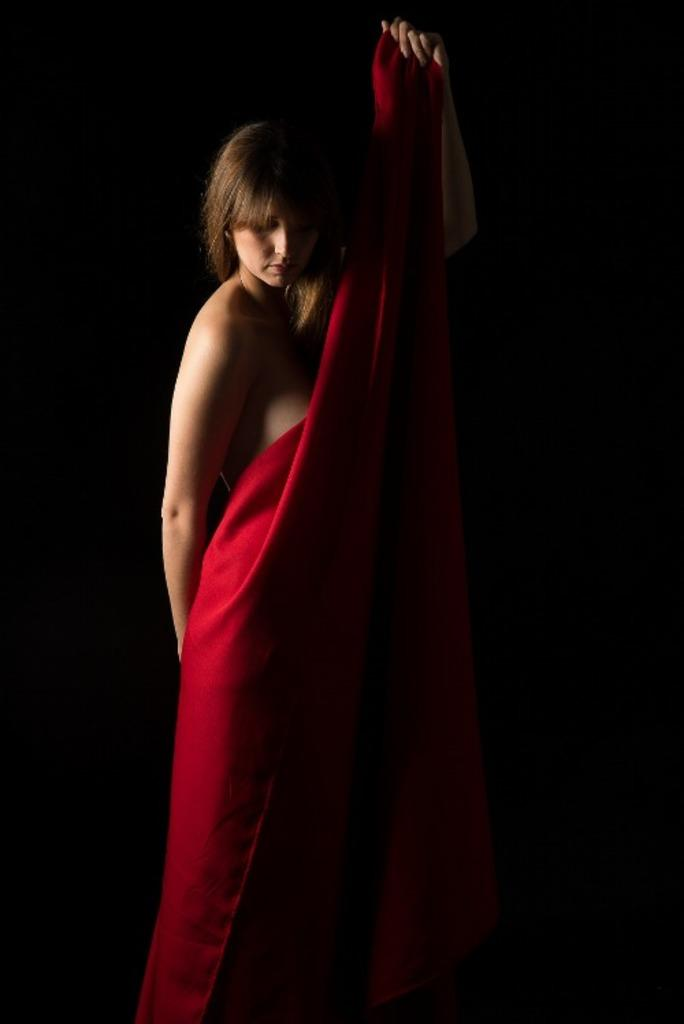Who is the main subject in the image? There is a woman in the image. What is the woman holding in her hand? The woman is holding a cloth in her hand. What can be observed about the background of the image? The background of the image is dark in color. Can we determine the time of day the image was taken? The image may have been taken during the night, given the dark background. How much wealth is the woman displaying in the image? There is no indication of wealth in the image; it only shows a woman holding a cloth. Is there a rainstorm occurring in the image? There is no rainstorm present in the image; the woman is holding a cloth in a dark background. 